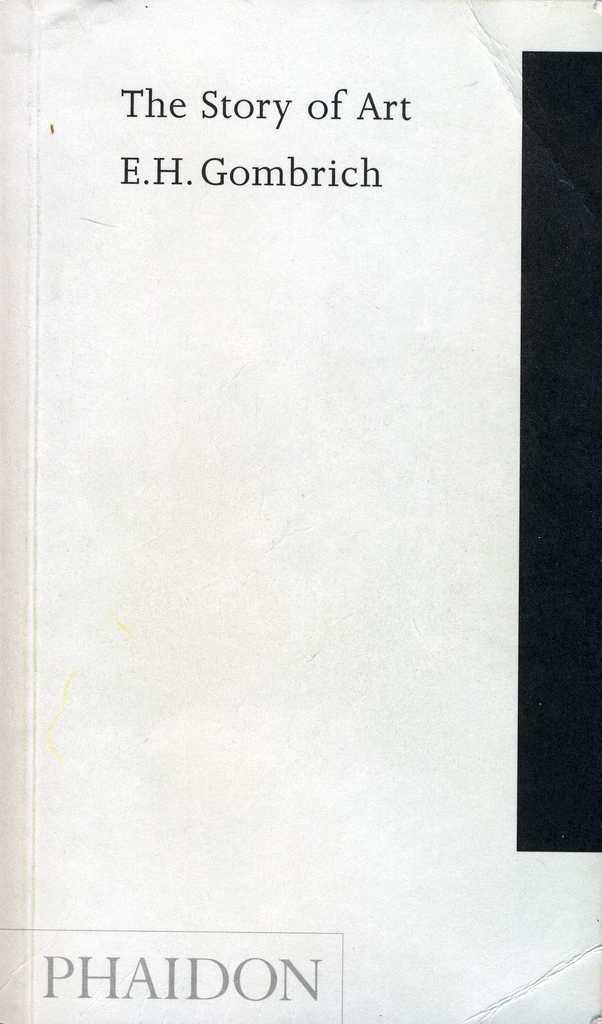What is the title of this book?
Ensure brevity in your answer.  The story of art. 